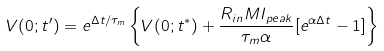<formula> <loc_0><loc_0><loc_500><loc_500>V ( 0 ; t ^ { \prime } ) = e ^ { \Delta t / \tau _ { m } } \left \{ V ( 0 ; t ^ { * } ) + \frac { R _ { i n } M I _ { p e a k } } { \tau _ { m } \alpha } [ e ^ { \alpha \Delta t } - 1 ] \right \}</formula> 